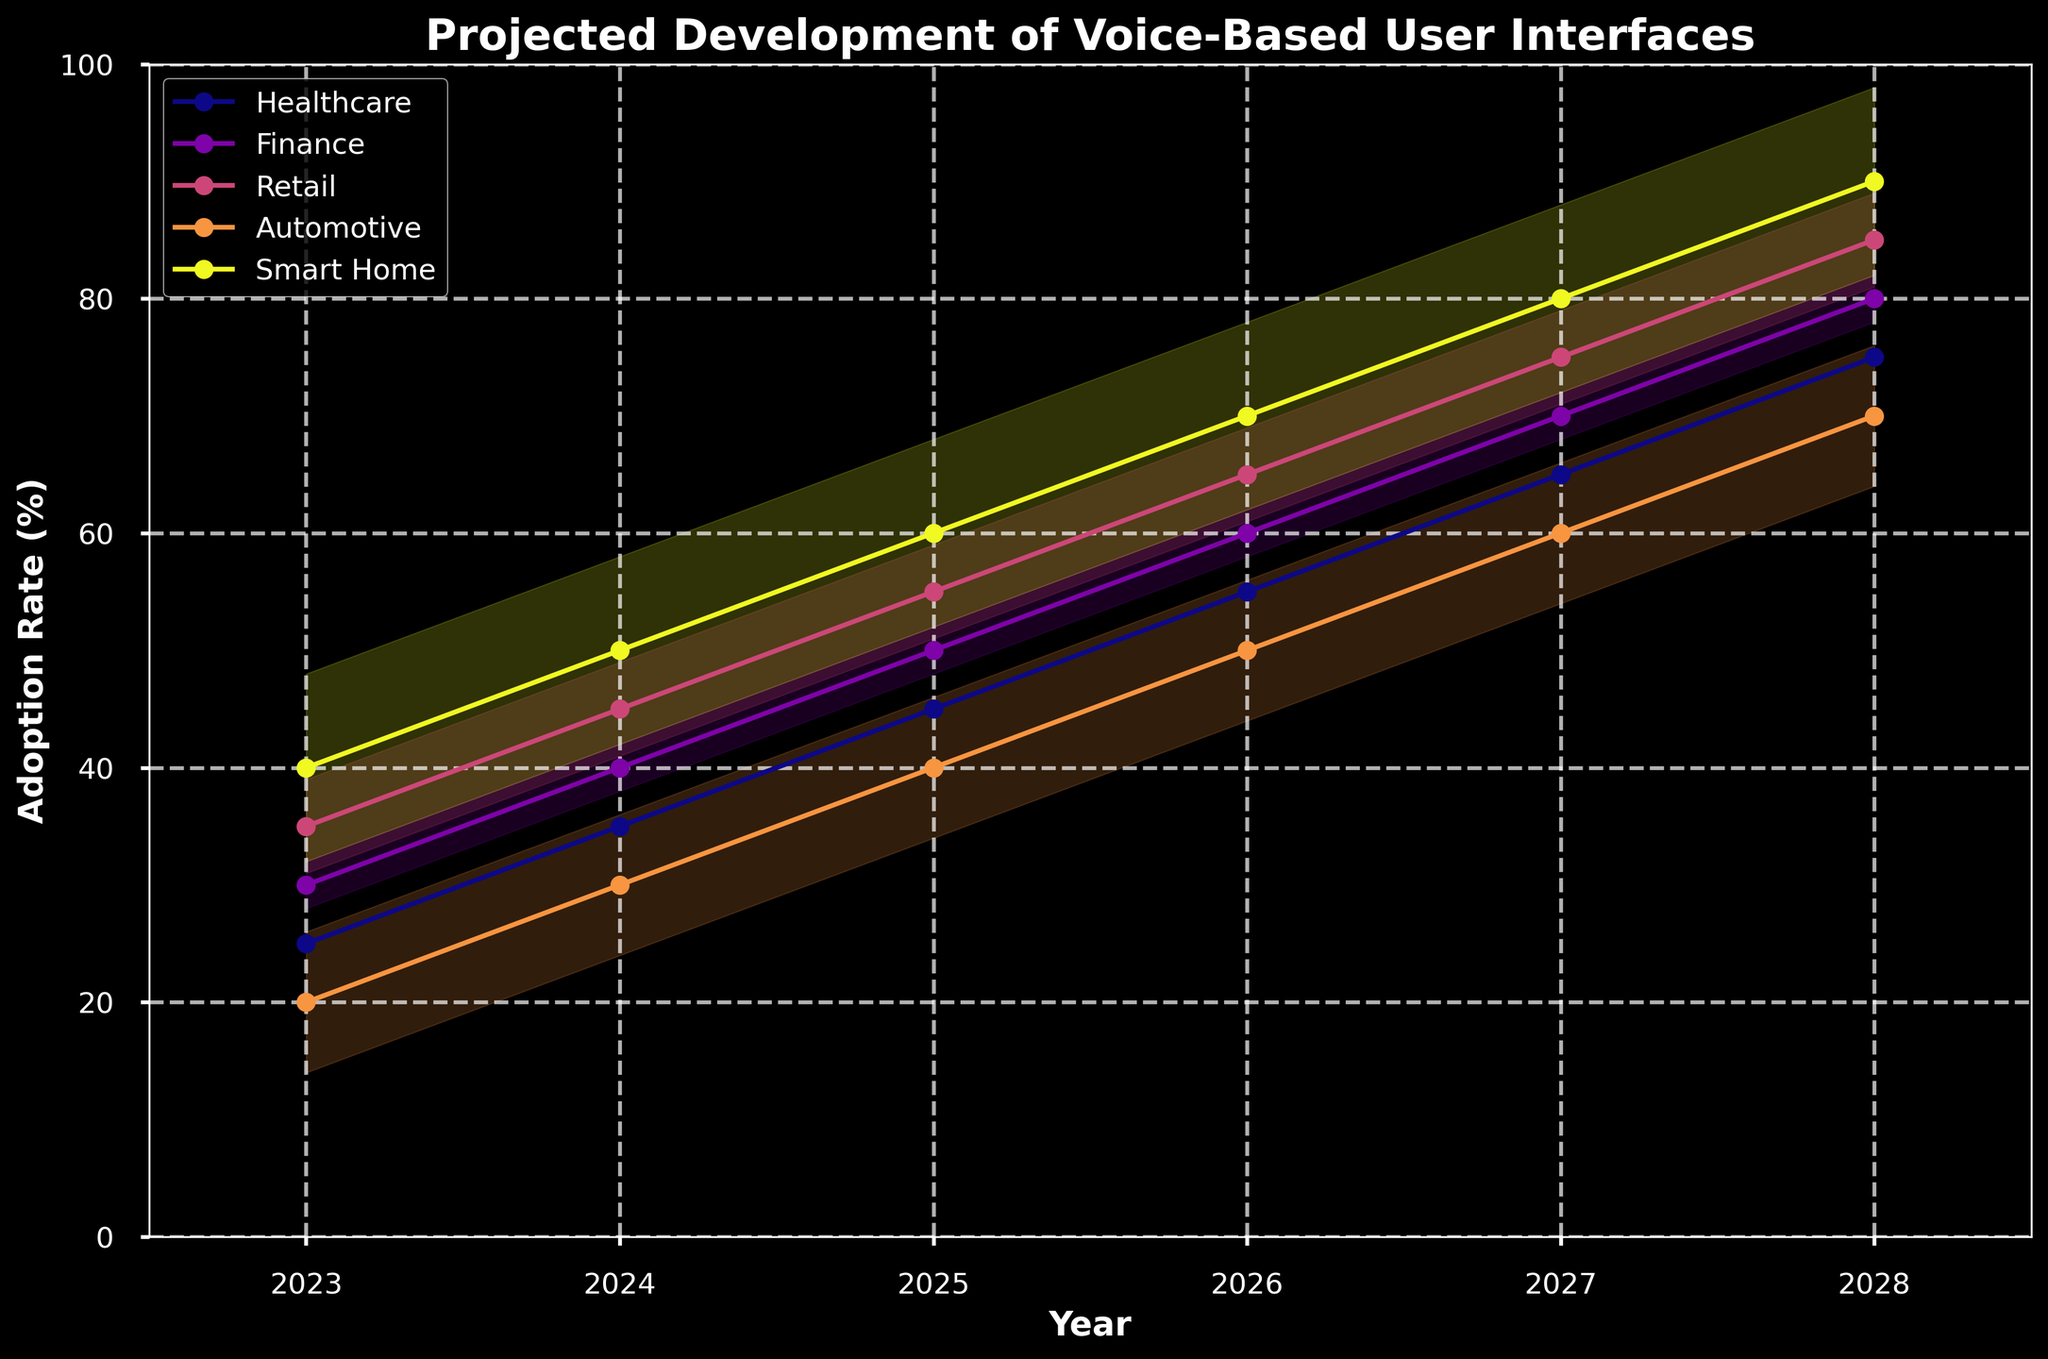What is the projected adoption rate for Smart Home industries in 2028? Look at the data points for the Smart Home industry in the figure and identify its value in 2028.
Answer: 90% How does the adoption rate of Retail change from 2023 to 2025? Find the adoption rates for Retail in 2023 and 2025 and calculate the difference. In 2023, it is 35%, and in 2025, it is 55%. The change is 55% - 35% = 20%.
Answer: Increases by 20% Which industry is expected to have the highest adoption rate in 2026? Compare the adoption rate values for all industries in 2026 and determine which is the highest.
Answer: Smart Home By how much is the adoption rate for Healthcare predicted to increase from 2023 to 2028? Find the adoption rates for Healthcare in 2023 and 2028 and calculate the difference. In 2023, it is 25%, and in 2028, it is 75%. The difference is 75% - 25% = 50%.
Answer: 50% What is the overall trend of adoption rates across all industries from 2023 to 2028? Observe the general direction of the lines representing different industries on the chart. All lines are increasing over the years from 2023 to 2028.
Answer: Increasing trend In 2027, which two industries are projected to have the closest adoption rates? Compare the projected adoption rates for each industry in 2027 and identify the two with the smallest difference.
Answer: Automotive and Healthcare Which industry shows the most significant projected growth in adoption rate from 2023 to 2027? Calculate the growth for each industry from 2023 to 2027 and compare which one has the largest increase. Smart Home grows from 40% to 80%, a difference of 40%, which is the largest.
Answer: Smart Home How does the adoption rate for Finance in 2024 compare to that of Automotive in the same year? Look at the adoption rate values for Finance and Automotive in 2024. Finance is at 40%, and Automotive is at 30%.
Answer: Finance is higher What's the range of the projected adoption rate for Retail in 2026, considering the fan effect? Determine the lower and upper bounds of the fan effect for Retail in 2026. The rate is 65%, with the fan effect of ±8 (4 levels), resulting in a range of 65%-8% to 65%+8% = 57% to 73%.
Answer: 57% to 73% What are the adoption rate values for all industries in 2025? Refer to the data for the year 2025 and list the values for each industry: Healthcare, Finance, Retail, Automotive, Smart Home as they appear in the figure.
Answer: 45%, 50%, 55%, 40%, 60% 